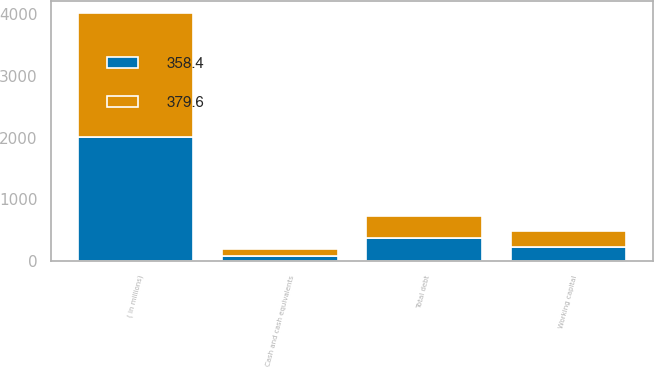Convert chart to OTSL. <chart><loc_0><loc_0><loc_500><loc_500><stacked_bar_chart><ecel><fcel>( in millions)<fcel>Cash and cash equivalents<fcel>Working capital<fcel>Total debt<nl><fcel>379.6<fcel>2010<fcel>110.2<fcel>266.9<fcel>358.4<nl><fcel>358.4<fcel>2009<fcel>83.1<fcel>226.1<fcel>379.6<nl></chart> 